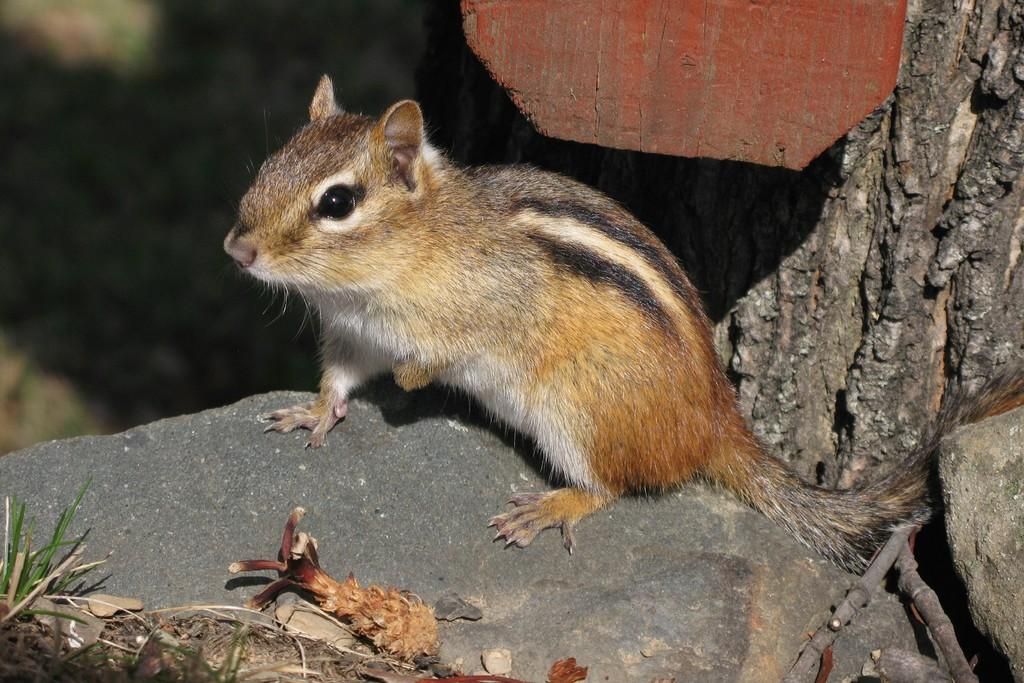What animal is present in the image? There is a squirrel in the image. What is the squirrel standing on? The squirrel is standing on a stone. What can be seen on the right side of the image? There is a tree trunk on the right side of the image. How would you describe the background of the image? The background of the image is blurry. What type of treatment is the squirrel receiving in the image? There is no indication in the image that the squirrel is receiving any treatment. 